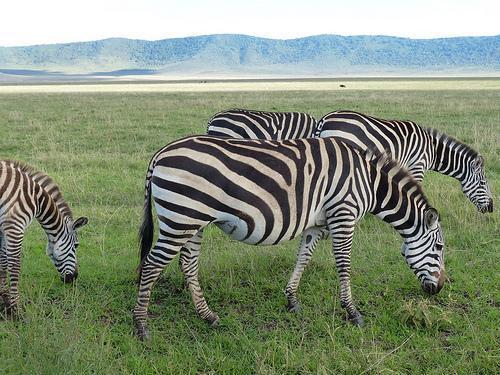How many zebras are there?
Give a very brief answer. 4. 